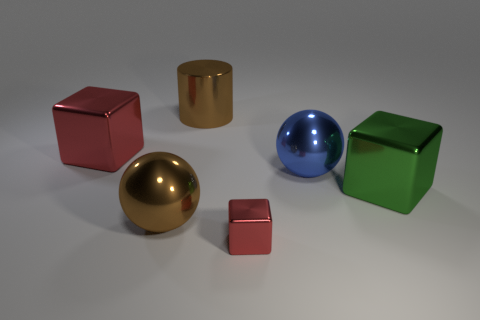What number of blue matte things have the same size as the blue sphere?
Ensure brevity in your answer.  0. What is the shape of the large metal object that is the same color as the big cylinder?
Give a very brief answer. Sphere. There is a red metallic object behind the large block that is to the right of the red thing in front of the green metal object; what is its shape?
Provide a short and direct response. Cube. There is a big thing left of the brown metal ball; what is its color?
Give a very brief answer. Red. What number of things are either big metal things that are to the right of the large red metallic cube or large things that are on the right side of the blue metal sphere?
Offer a terse response. 4. What number of large green things have the same shape as the blue metal object?
Provide a short and direct response. 0. The block that is the same size as the green object is what color?
Your response must be concise. Red. The shiny ball behind the block on the right side of the red object to the right of the large brown shiny ball is what color?
Your answer should be very brief. Blue. There is a green shiny block; is it the same size as the red metal object behind the blue shiny ball?
Provide a succinct answer. Yes. What number of things are either tiny green rubber spheres or large blocks?
Offer a very short reply. 2. 